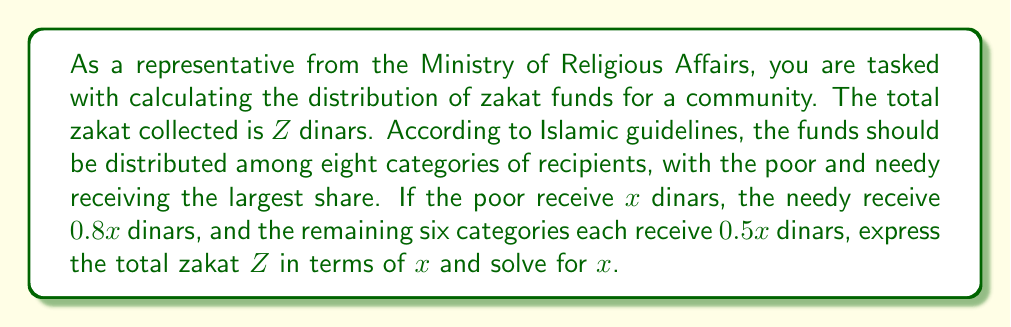Help me with this question. To solve this problem, we'll follow these steps:

1) First, let's express the amount each category receives in terms of $x$:
   - Poor: $x$ dinars
   - Needy: $0.8x$ dinars
   - Each of the remaining 6 categories: $0.5x$ dinars

2) Now, we can set up an equation where the sum of all distributions equals the total zakat $Z$:

   $$Z = x + 0.8x + 6(0.5x)$$

3) Simplify the right side of the equation:
   $$Z = x + 0.8x + 3x$$
   $$Z = 4.8x$$

4) To solve for $x$, divide both sides by 4.8:

   $$\frac{Z}{4.8} = x$$

5) Therefore, the amount allocated to the poor (x) can be expressed as:

   $$x = \frac{Z}{4.8}$$

This formula allows us to calculate the distribution for each category based on the total zakat collected:
- Poor: $\frac{Z}{4.8}$
- Needy: $0.8 \cdot \frac{Z}{4.8} = \frac{Z}{6}$
- Each of the remaining 6 categories: $0.5 \cdot \frac{Z}{4.8} = \frac{Z}{9.6}$
Answer: $$x = \frac{Z}{4.8}$$
where $x$ is the amount allocated to the poor and $Z$ is the total zakat collected. 